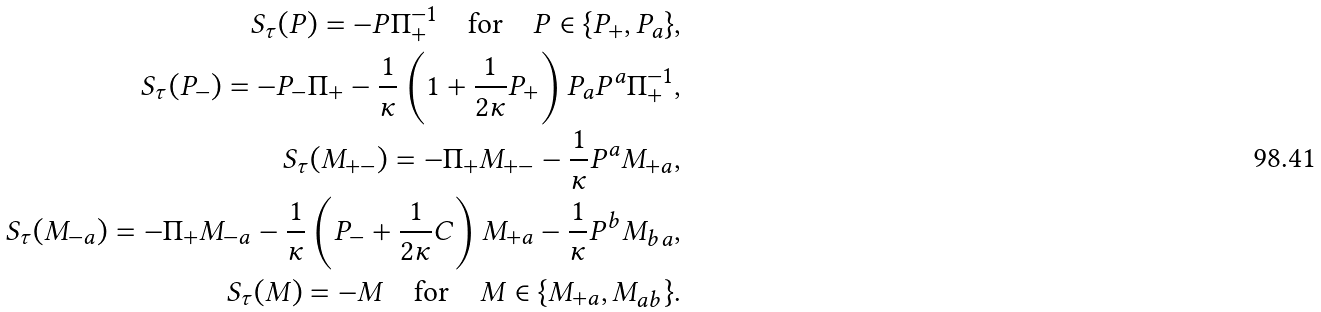<formula> <loc_0><loc_0><loc_500><loc_500>S _ { \tau } ( P ) = - P \Pi _ { + } ^ { - 1 } \quad \text {for} \quad P \in \{ P _ { + } , P _ { a } \} , \\ S _ { \tau } ( P _ { - } ) = - P _ { - } \Pi _ { + } - \frac { 1 } { \kappa } \left ( 1 + \frac { 1 } { 2 \kappa } P _ { + } \right ) P _ { a } P ^ { a } \Pi _ { + } ^ { - 1 } , \\ S _ { \tau } ( M _ { + - } ) = - \Pi _ { + } M _ { + - } - \frac { 1 } { \kappa } P ^ { a } M _ { + a } , \\ S _ { \tau } ( M _ { - a } ) = - \Pi _ { + } M _ { - a } - \frac { 1 } { \kappa } \left ( P _ { - } + \frac { 1 } { 2 \kappa } C \right ) M _ { + a } - \frac { 1 } { \kappa } P ^ { b } M _ { b a } , \\ S _ { \tau } ( M ) = - M \quad \text {for} \quad M \in \{ M _ { + a } , M _ { a b } \} .</formula> 